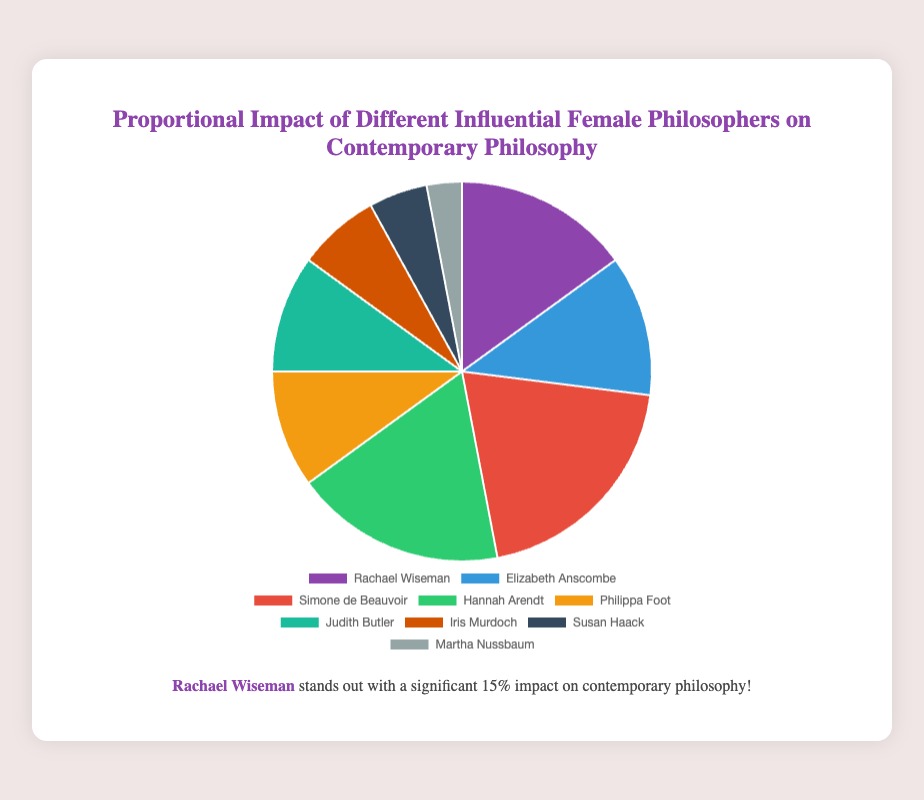What's the proportional impact of Judith Butler and Iris Murdoch combined? Add the proportional impact values for both Judith Butler (10%) and Iris Murdoch (7%). Thus, 10 + 7 = 17.
Answer: 17% Who has a greater impact, Rachael Wiseman or Hannah Arendt? Compare the proportional impact values: Rachael Wiseman has 15% and Hannah Arendt has 18%. Since 18 is greater than 15, Hannah Arendt has a greater impact.
Answer: Hannah Arendt Which philosopher has the least impact on contemporary philosophy? Identify the philosopher with the smallest proportional impact value. Martha Nussbaum has the smallest value at 3%.
Answer: Martha Nussbaum What is the difference in impact between Rachael Wiseman and Elizabeth Anscombe? Subtract the proportional impact of Elizabeth Anscombe (12%) from that of Rachael Wiseman (15%). So, 15 - 12 = 3.
Answer: 3% Which philosophical impact is represented by the color green? Look at the color green on the pie chart and identify the corresponding philosopher. The color green represents Hannah Arendt.
Answer: Hannah Arendt Order the philosophers with an impact greater than 10% from most to least impactful. List the philosophers whose impact is greater than 10% and order them: Simone de Beauvoir (20%), Hannah Arendt (18%), Rachael Wiseman (15%), Elizabeth Anscombe (12%).
Answer: Simone de Beauvoir, Hannah Arendt, Rachael Wiseman, Elizabeth Anscombe What is the total proportional impact of the philosophers not highlighted in the legend description? Add the proportional impact values of all philosophers excluding Rachael Wiseman. So, 12 + 20 + 18 + 10 + 10 + 7 + 5 + 3 = 85.
Answer: 85% What is the average proportional impact of all the listed philosophers? Divide the sum of the proportional impacts by the number of philosophers: (15 + 12 + 20 + 18 + 10 + 10 + 7 + 5 + 3) / 9 = 100 / 9 ≈ 11.1.
Answer: 11.1% Which philosopher's impact makes up exactly twice that of Susan Haack? Find the impact that is twice Susan Haack's (5%), which is 2 * 5 = 10%. Both Philippa Foot and Judith Butler have a 10% impact.
Answer: Philippa Foot, Judith Butler 